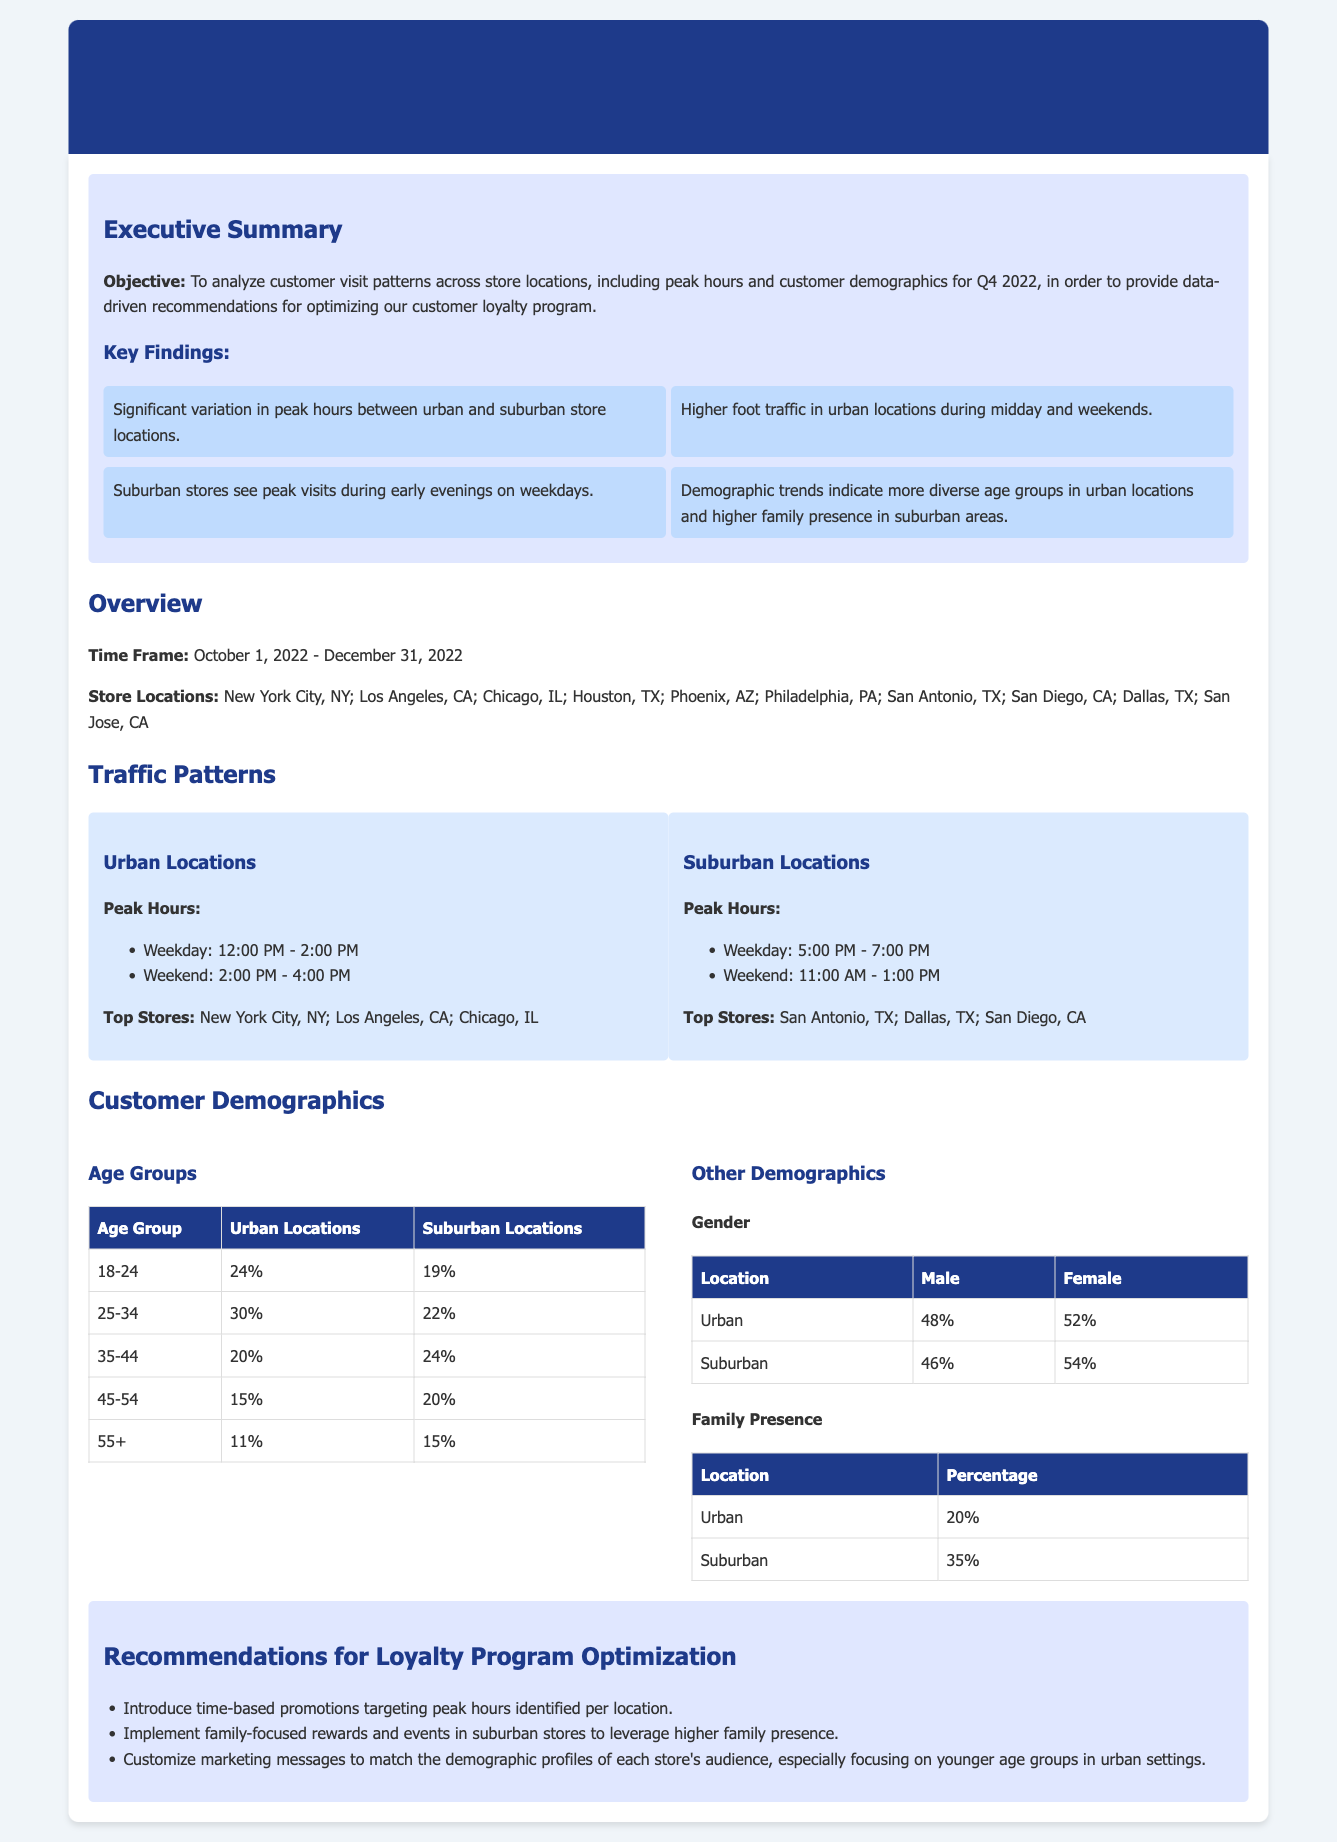What are the peak hours for urban locations on weekdays? The peak hours for urban locations on weekdays are identified in the traffic patterns section of the report.
Answer: 12:00 PM - 2:00 PM What is the percentage of the 25-34 age group in suburban locations? The percentage of the 25-34 age group can be found in the customer demographics table in the document.
Answer: 22% Which city has the highest foot traffic among urban locations? The top stores listed in the report indicate which urban location has the highest foot traffic.
Answer: New York City, NY What percentage of customers in suburban locations are family-oriented? The percentage of family presence in suburban locations is stated in the other demographics section of the document.
Answer: 35% What demographic group accounts for 24% of visits in suburban locations? This information is found in the age groups table, showing the percentages for each age group per location.
Answer: 35-44 What is the main focus of the recommendations section? The recommendations section is based on insights from the traffic analysis and demographics, suggesting optimizations for the loyalty program.
Answer: Optimize the loyalty program What are the peak hours for suburban locations on weekends? The document mentions specific peak hours for suburban locations on weekends in the traffic patterns section.
Answer: 11:00 AM - 1:00 PM What percentage of urban customers are male? The percentage of male customers in urban locations can be found in the gender demographics table.
Answer: 48% Which age group has the lowest representation in urban locations? This information is in the age groups table that shows the distribution of visits by age group.
Answer: 55+ 